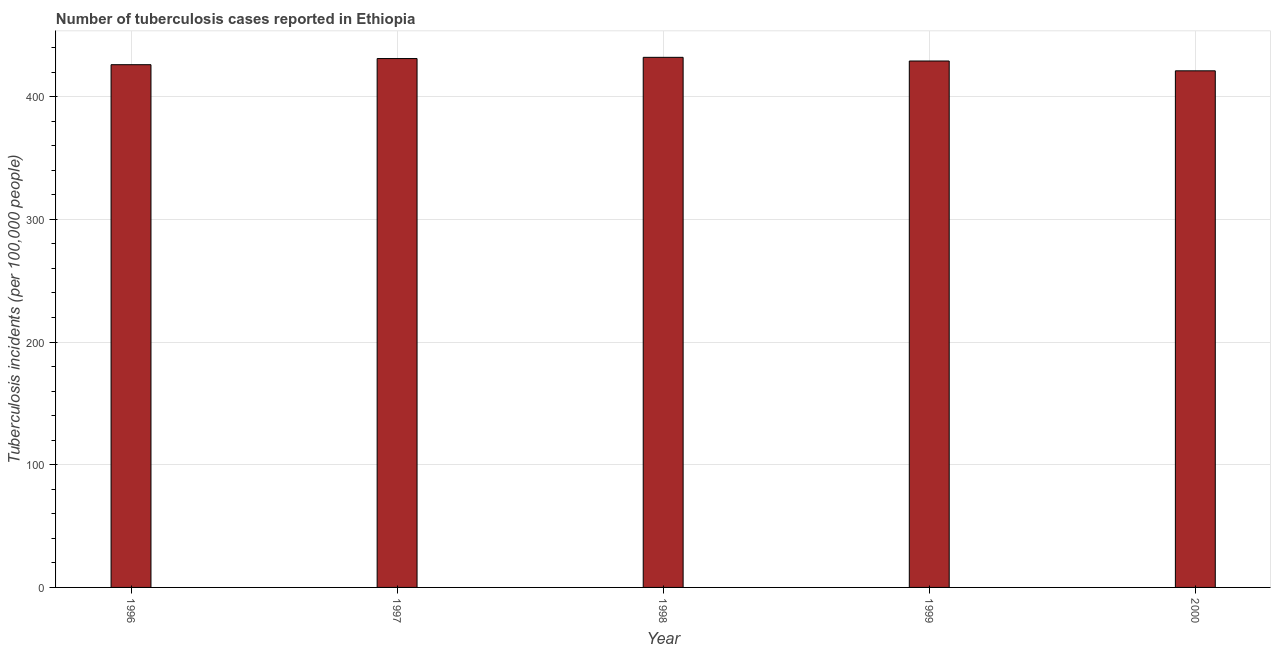Does the graph contain any zero values?
Offer a terse response. No. What is the title of the graph?
Your response must be concise. Number of tuberculosis cases reported in Ethiopia. What is the label or title of the Y-axis?
Offer a very short reply. Tuberculosis incidents (per 100,0 people). What is the number of tuberculosis incidents in 1996?
Keep it short and to the point. 426. Across all years, what is the maximum number of tuberculosis incidents?
Provide a succinct answer. 432. Across all years, what is the minimum number of tuberculosis incidents?
Offer a terse response. 421. What is the sum of the number of tuberculosis incidents?
Ensure brevity in your answer.  2139. What is the difference between the number of tuberculosis incidents in 1996 and 2000?
Ensure brevity in your answer.  5. What is the average number of tuberculosis incidents per year?
Provide a short and direct response. 427. What is the median number of tuberculosis incidents?
Offer a very short reply. 429. In how many years, is the number of tuberculosis incidents greater than 380 ?
Your response must be concise. 5. Is the sum of the number of tuberculosis incidents in 1996 and 2000 greater than the maximum number of tuberculosis incidents across all years?
Give a very brief answer. Yes. How many years are there in the graph?
Your answer should be compact. 5. Are the values on the major ticks of Y-axis written in scientific E-notation?
Provide a succinct answer. No. What is the Tuberculosis incidents (per 100,000 people) of 1996?
Offer a terse response. 426. What is the Tuberculosis incidents (per 100,000 people) in 1997?
Keep it short and to the point. 431. What is the Tuberculosis incidents (per 100,000 people) in 1998?
Keep it short and to the point. 432. What is the Tuberculosis incidents (per 100,000 people) of 1999?
Your response must be concise. 429. What is the Tuberculosis incidents (per 100,000 people) in 2000?
Offer a very short reply. 421. What is the difference between the Tuberculosis incidents (per 100,000 people) in 1996 and 1997?
Offer a terse response. -5. What is the difference between the Tuberculosis incidents (per 100,000 people) in 1996 and 2000?
Your response must be concise. 5. What is the difference between the Tuberculosis incidents (per 100,000 people) in 1997 and 1999?
Offer a very short reply. 2. What is the difference between the Tuberculosis incidents (per 100,000 people) in 1997 and 2000?
Provide a short and direct response. 10. What is the difference between the Tuberculosis incidents (per 100,000 people) in 1998 and 1999?
Your response must be concise. 3. What is the difference between the Tuberculosis incidents (per 100,000 people) in 1998 and 2000?
Make the answer very short. 11. What is the difference between the Tuberculosis incidents (per 100,000 people) in 1999 and 2000?
Your answer should be very brief. 8. What is the ratio of the Tuberculosis incidents (per 100,000 people) in 1996 to that in 1998?
Your answer should be very brief. 0.99. What is the ratio of the Tuberculosis incidents (per 100,000 people) in 1997 to that in 1998?
Give a very brief answer. 1. What is the ratio of the Tuberculosis incidents (per 100,000 people) in 1997 to that in 2000?
Your answer should be very brief. 1.02. What is the ratio of the Tuberculosis incidents (per 100,000 people) in 1998 to that in 1999?
Ensure brevity in your answer.  1.01. What is the ratio of the Tuberculosis incidents (per 100,000 people) in 1999 to that in 2000?
Your response must be concise. 1.02. 